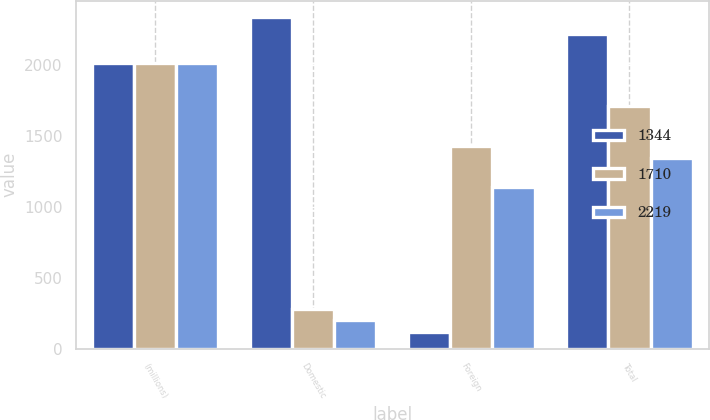Convert chart. <chart><loc_0><loc_0><loc_500><loc_500><stacked_bar_chart><ecel><fcel>(millions)<fcel>Domestic<fcel>Foreign<fcel>Total<nl><fcel>1344<fcel>2015<fcel>2338<fcel>119<fcel>2219<nl><fcel>1710<fcel>2014<fcel>282<fcel>1428<fcel>1710<nl><fcel>2219<fcel>2013<fcel>202<fcel>1142<fcel>1344<nl></chart> 